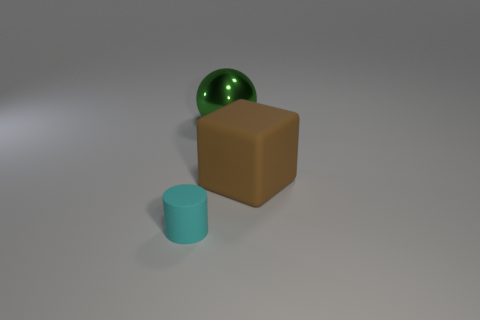Is the number of green metallic spheres less than the number of cyan metallic blocks?
Your response must be concise. No. There is a brown matte thing; does it have the same size as the matte thing that is to the left of the large green thing?
Keep it short and to the point. No. Are there any other things that have the same shape as the green object?
Keep it short and to the point. No. What size is the cube?
Provide a succinct answer. Large. Are there fewer large rubber cubes in front of the big brown rubber object than large shiny cubes?
Your response must be concise. No. Is the green shiny thing the same size as the brown block?
Give a very brief answer. Yes. Are there any other things that are the same size as the cylinder?
Your answer should be very brief. No. What color is the other tiny object that is made of the same material as the brown object?
Ensure brevity in your answer.  Cyan. Are there fewer brown cubes in front of the rubber cylinder than matte objects to the left of the big shiny ball?
Give a very brief answer. Yes. How many objects are both in front of the green metal object and left of the brown rubber block?
Ensure brevity in your answer.  1. 